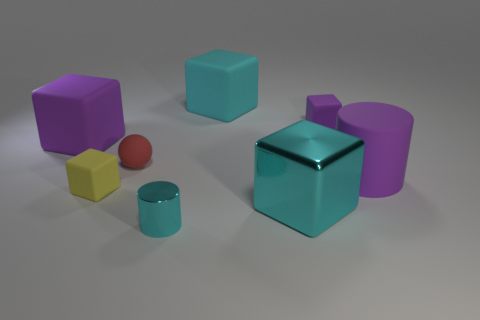There is a purple block to the right of the cyan cylinder; what material is it?
Your response must be concise. Rubber. The big purple rubber object that is on the left side of the yellow thing that is in front of the large purple matte thing on the right side of the big metal thing is what shape?
Your answer should be compact. Cube. Does the tiny matte block on the right side of the tiny shiny cylinder have the same color as the cylinder behind the large shiny object?
Offer a very short reply. Yes. Are there fewer yellow matte cubes that are right of the big metallic cube than purple blocks to the left of the large purple matte cube?
Your response must be concise. No. Is there any other thing that is the same shape as the small cyan object?
Keep it short and to the point. Yes. There is a large metal thing that is the same shape as the small yellow rubber object; what color is it?
Provide a succinct answer. Cyan. There is a small purple object; is its shape the same as the large object that is on the left side of the yellow matte object?
Ensure brevity in your answer.  Yes. How many objects are cyan cubes that are in front of the small red rubber ball or shiny objects that are in front of the purple rubber cylinder?
Offer a very short reply. 2. What is the material of the red thing?
Your answer should be very brief. Rubber. There is a purple thing that is left of the matte sphere; what is its size?
Offer a terse response. Large. 